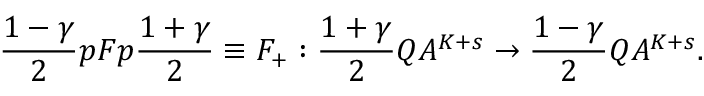Convert formula to latex. <formula><loc_0><loc_0><loc_500><loc_500>\frac { 1 - \gamma } { 2 } p F p \frac { 1 + \gamma } { 2 } \equiv F _ { + } \colon \frac { 1 + \gamma } { 2 } Q A ^ { K + s } \rightarrow \frac { 1 - \gamma } { 2 } Q A ^ { K + s } .</formula> 